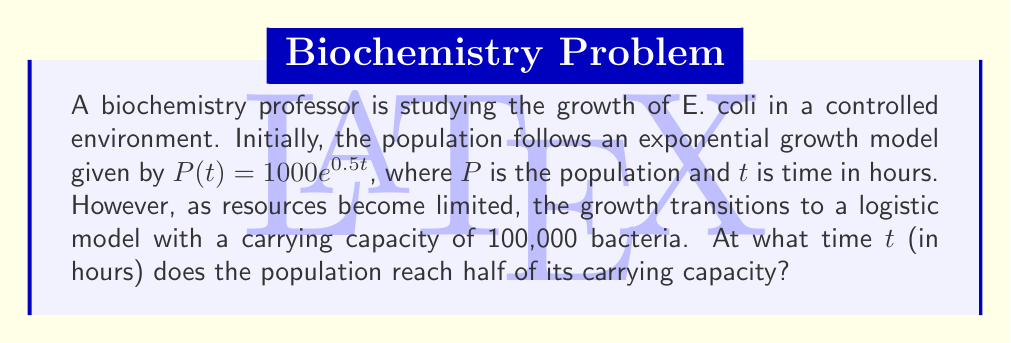Teach me how to tackle this problem. Let's approach this step-by-step:

1) The logistic growth model is given by the formula:

   $$P(t) = \frac{K}{1 + Ae^{-rt}}$$

   where $K$ is the carrying capacity, $A$ is a constant, and $r$ is the growth rate.

2) We're asked to find when the population reaches half the carrying capacity. This means:

   $$P(t) = \frac{K}{2} = 50,000$$

3) Substituting this into the logistic equation:

   $$50,000 = \frac{100,000}{1 + Ae^{-rt}}$$

4) Simplifying:

   $$1 + Ae^{-rt} = 2$$
   $$Ae^{-rt} = 1$$

5) Taking the natural log of both sides:

   $$\ln(A) - rt = 0$$
   $$t = \frac{\ln(A)}{r}$$

6) To find $A$ and $r$, we can use the initial exponential growth model:

   $$1000e^{0.5t} = \frac{100,000}{1 + Ae^{-rt}}$$

7) Comparing this to the standard form of exponential growth $(P_0e^{rt})$, we can see that $r = 0.5$.

8) When $t = 0$, the initial population is 1000:

   $$1000 = \frac{100,000}{1 + A}$$
   $$A = 99$$

9) Now we can solve for $t$:

   $$t = \frac{\ln(99)}{0.5} \approx 9.19$$
Answer: $9.19$ hours 